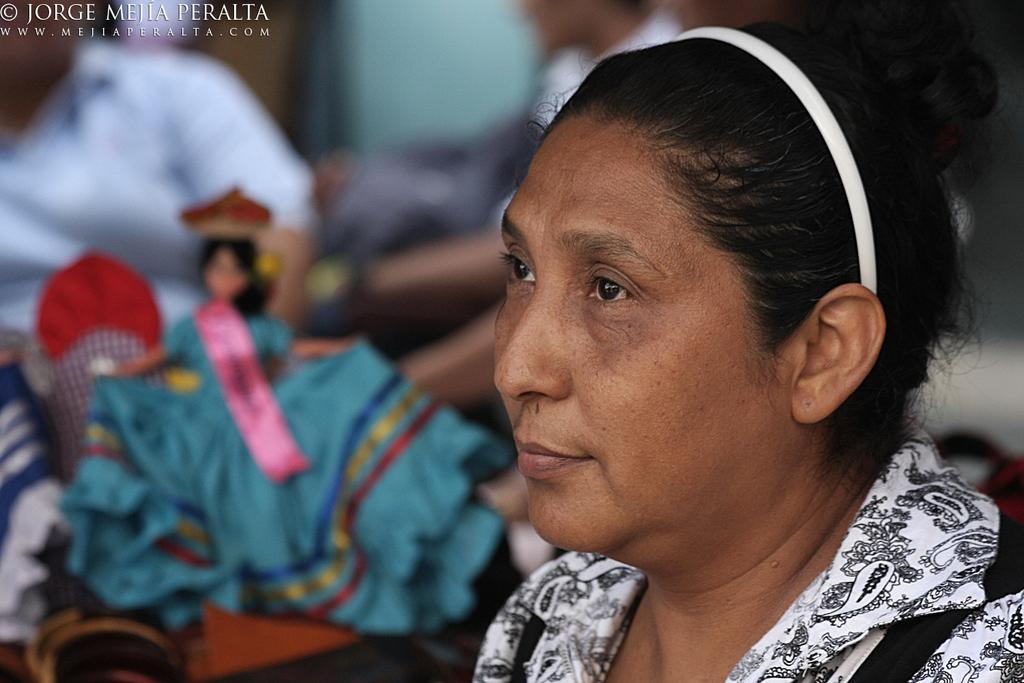Who is the main subject in the image? There is a lady in the image. What object is on the left side of the image? There is a doll on the left side of the image. Can you describe the background of the image? There are people in the background of the image. What is written or visible at the top of the image? There is text visible at the top of the image. How many cows are present in the image? There are no cows present in the image. What type of vacation is the lady planning in the image? The image does not provide any information about a vacation or the lady's plans. 